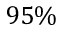Convert formula to latex. <formula><loc_0><loc_0><loc_500><loc_500>9 5 \%</formula> 